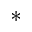<formula> <loc_0><loc_0><loc_500><loc_500>^ { * }</formula> 